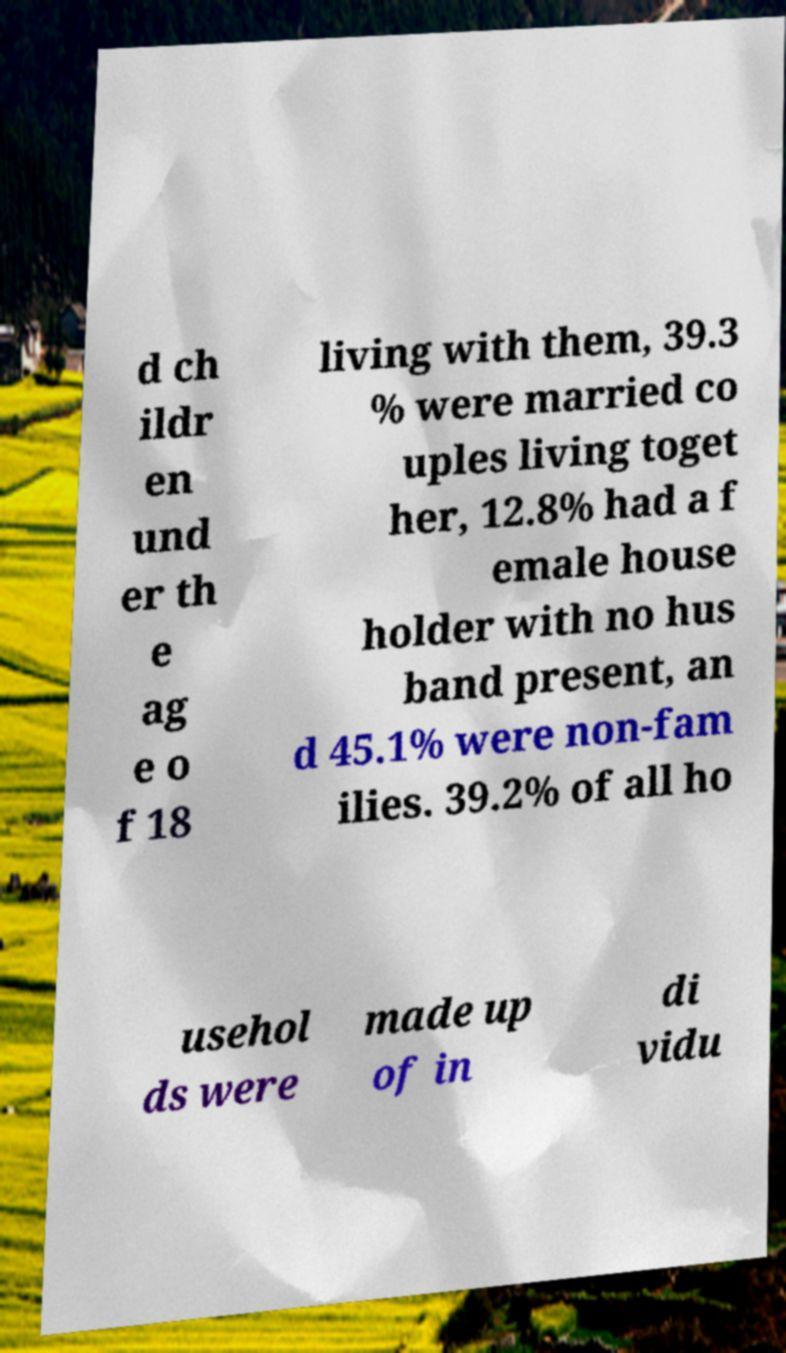Can you accurately transcribe the text from the provided image for me? d ch ildr en und er th e ag e o f 18 living with them, 39.3 % were married co uples living toget her, 12.8% had a f emale house holder with no hus band present, an d 45.1% were non-fam ilies. 39.2% of all ho usehol ds were made up of in di vidu 